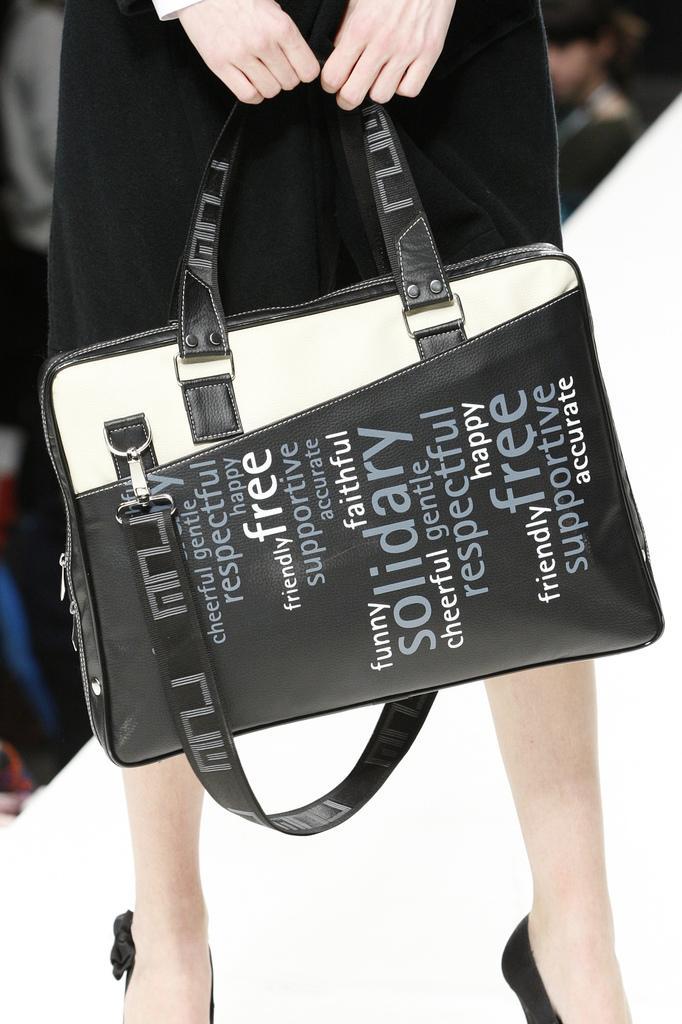Can you describe this image briefly? In the middle there is a woman she is holding a hand bag ,there is some text written on that bag she is wearing a black dress. In the background there are some people. 